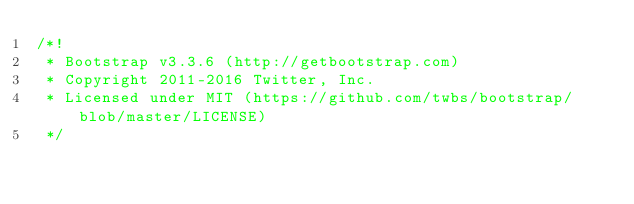<code> <loc_0><loc_0><loc_500><loc_500><_CSS_>/*!
 * Bootstrap v3.3.6 (http://getbootstrap.com)
 * Copyright 2011-2016 Twitter, Inc.
 * Licensed under MIT (https://github.com/twbs/bootstrap/blob/master/LICENSE)
 */</code> 